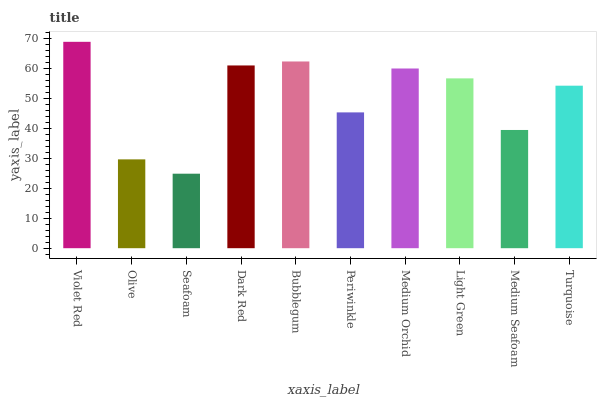Is Seafoam the minimum?
Answer yes or no. Yes. Is Violet Red the maximum?
Answer yes or no. Yes. Is Olive the minimum?
Answer yes or no. No. Is Olive the maximum?
Answer yes or no. No. Is Violet Red greater than Olive?
Answer yes or no. Yes. Is Olive less than Violet Red?
Answer yes or no. Yes. Is Olive greater than Violet Red?
Answer yes or no. No. Is Violet Red less than Olive?
Answer yes or no. No. Is Light Green the high median?
Answer yes or no. Yes. Is Turquoise the low median?
Answer yes or no. Yes. Is Dark Red the high median?
Answer yes or no. No. Is Medium Orchid the low median?
Answer yes or no. No. 